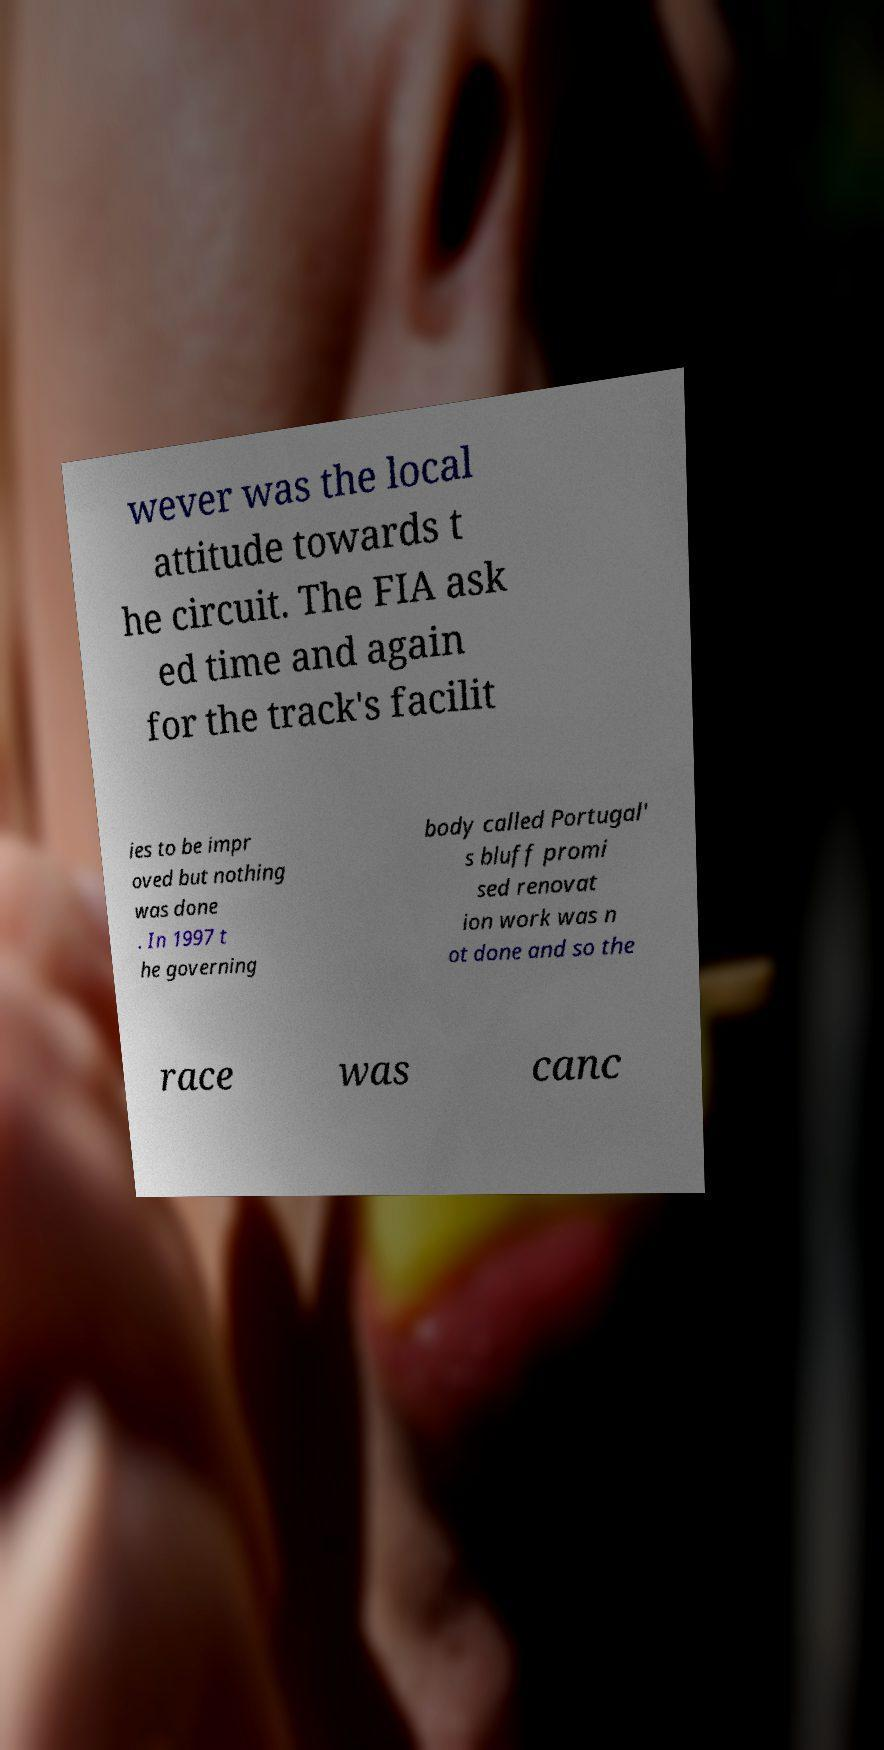Could you assist in decoding the text presented in this image and type it out clearly? wever was the local attitude towards t he circuit. The FIA ask ed time and again for the track's facilit ies to be impr oved but nothing was done . In 1997 t he governing body called Portugal' s bluff promi sed renovat ion work was n ot done and so the race was canc 